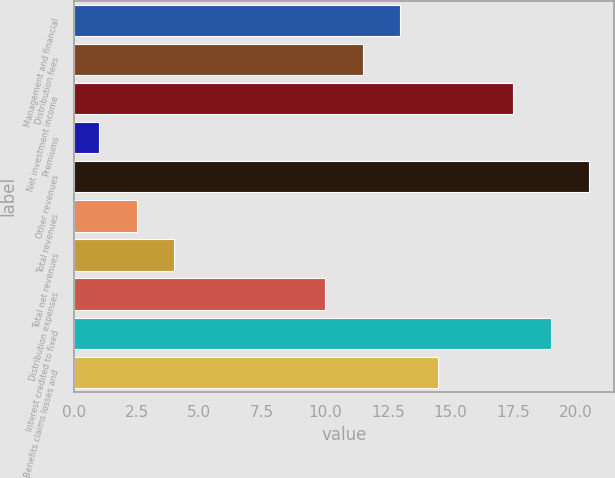<chart> <loc_0><loc_0><loc_500><loc_500><bar_chart><fcel>Management and financial<fcel>Distribution fees<fcel>Net investment income<fcel>Premiums<fcel>Other revenues<fcel>Total revenues<fcel>Total net revenues<fcel>Distribution expenses<fcel>Interest credited to fixed<fcel>Benefits claims losses and<nl><fcel>13<fcel>11.5<fcel>17.5<fcel>1<fcel>20.5<fcel>2.5<fcel>4<fcel>10<fcel>19<fcel>14.5<nl></chart> 